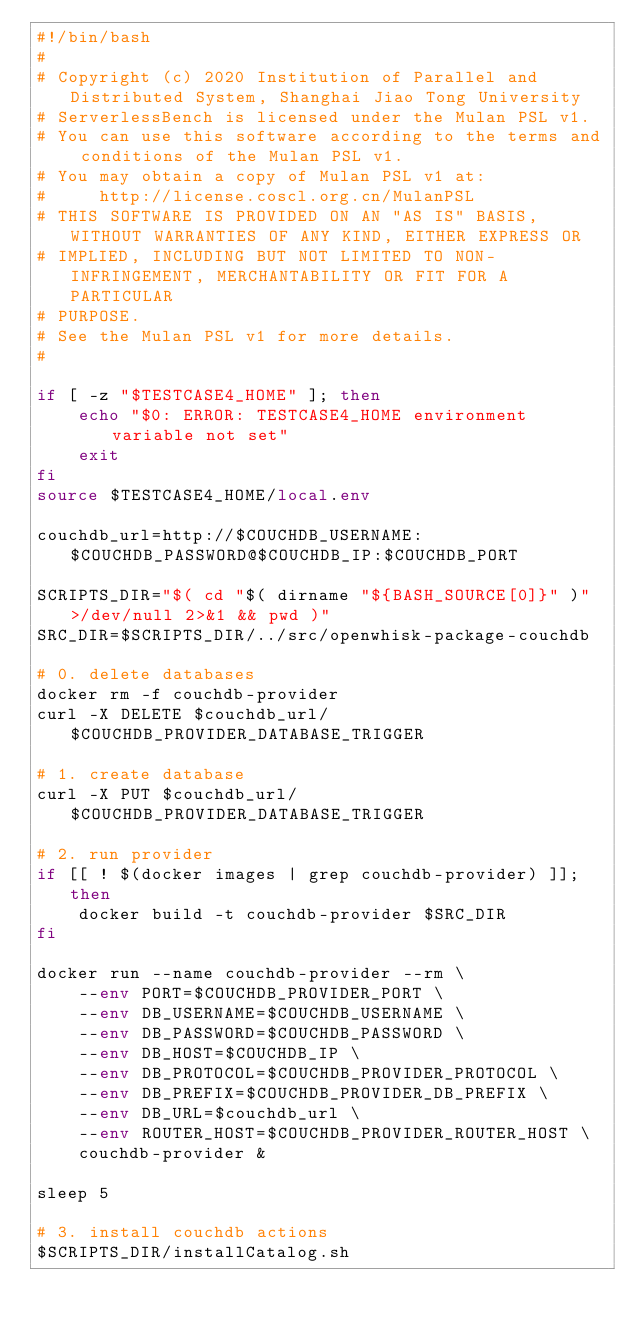Convert code to text. <code><loc_0><loc_0><loc_500><loc_500><_Bash_>#!/bin/bash
#
# Copyright (c) 2020 Institution of Parallel and Distributed System, Shanghai Jiao Tong University
# ServerlessBench is licensed under the Mulan PSL v1.
# You can use this software according to the terms and conditions of the Mulan PSL v1.
# You may obtain a copy of Mulan PSL v1 at:
#     http://license.coscl.org.cn/MulanPSL
# THIS SOFTWARE IS PROVIDED ON AN "AS IS" BASIS, WITHOUT WARRANTIES OF ANY KIND, EITHER EXPRESS OR
# IMPLIED, INCLUDING BUT NOT LIMITED TO NON-INFRINGEMENT, MERCHANTABILITY OR FIT FOR A PARTICULAR
# PURPOSE.
# See the Mulan PSL v1 for more details.
#

if [ -z "$TESTCASE4_HOME" ]; then
    echo "$0: ERROR: TESTCASE4_HOME environment variable not set"
    exit
fi
source $TESTCASE4_HOME/local.env

couchdb_url=http://$COUCHDB_USERNAME:$COUCHDB_PASSWORD@$COUCHDB_IP:$COUCHDB_PORT

SCRIPTS_DIR="$( cd "$( dirname "${BASH_SOURCE[0]}" )" >/dev/null 2>&1 && pwd )"
SRC_DIR=$SCRIPTS_DIR/../src/openwhisk-package-couchdb

# 0. delete databases
docker rm -f couchdb-provider
curl -X DELETE $couchdb_url/$COUCHDB_PROVIDER_DATABASE_TRIGGER

# 1. create database
curl -X PUT $couchdb_url/$COUCHDB_PROVIDER_DATABASE_TRIGGER

# 2. run provider
if [[ ! $(docker images | grep couchdb-provider) ]]; then
    docker build -t couchdb-provider $SRC_DIR
fi

docker run --name couchdb-provider --rm \
    --env PORT=$COUCHDB_PROVIDER_PORT \
    --env DB_USERNAME=$COUCHDB_USERNAME \
    --env DB_PASSWORD=$COUCHDB_PASSWORD \
    --env DB_HOST=$COUCHDB_IP \
    --env DB_PROTOCOL=$COUCHDB_PROVIDER_PROTOCOL \
    --env DB_PREFIX=$COUCHDB_PROVIDER_DB_PREFIX \
    --env DB_URL=$couchdb_url \
    --env ROUTER_HOST=$COUCHDB_PROVIDER_ROUTER_HOST \
    couchdb-provider &

sleep 5

# 3. install couchdb actions
$SCRIPTS_DIR/installCatalog.sh
</code> 